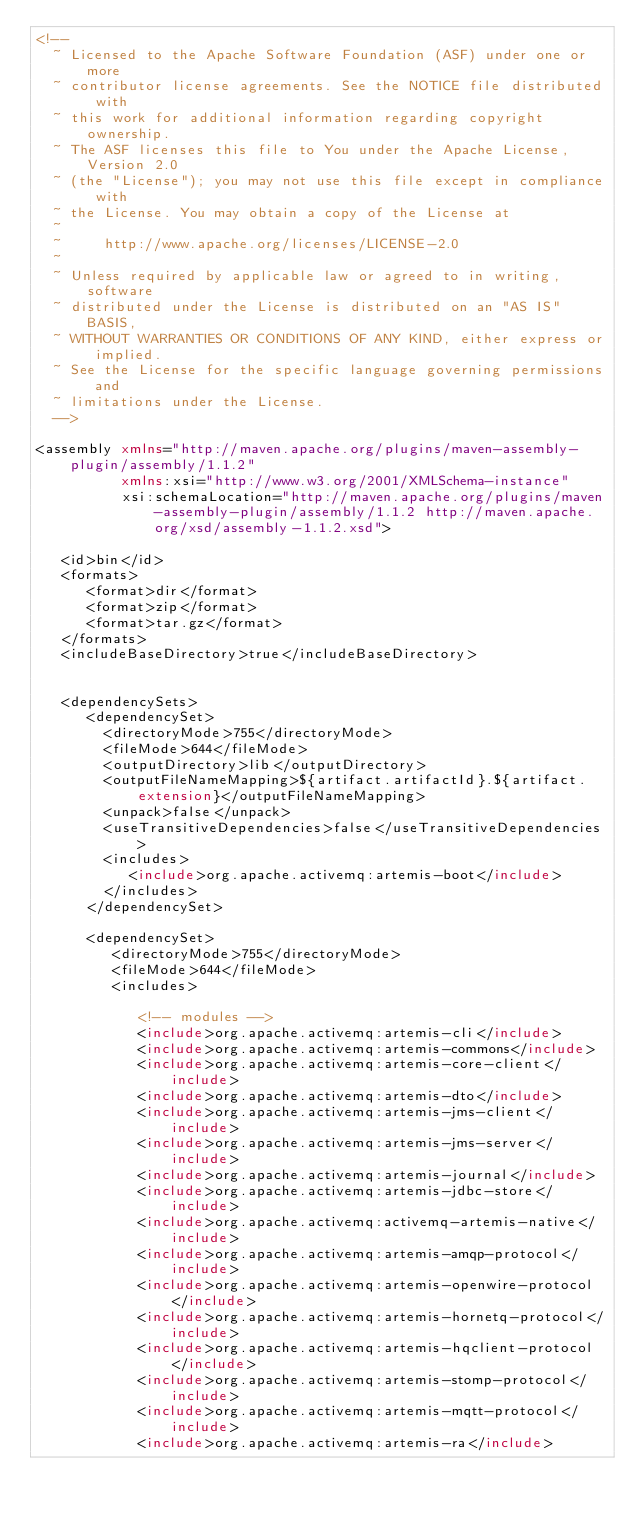Convert code to text. <code><loc_0><loc_0><loc_500><loc_500><_XML_><!--
  ~ Licensed to the Apache Software Foundation (ASF) under one or more
  ~ contributor license agreements. See the NOTICE file distributed with
  ~ this work for additional information regarding copyright ownership.
  ~ The ASF licenses this file to You under the Apache License, Version 2.0
  ~ (the "License"); you may not use this file except in compliance with
  ~ the License. You may obtain a copy of the License at
  ~
  ~     http://www.apache.org/licenses/LICENSE-2.0
  ~
  ~ Unless required by applicable law or agreed to in writing, software
  ~ distributed under the License is distributed on an "AS IS" BASIS,
  ~ WITHOUT WARRANTIES OR CONDITIONS OF ANY KIND, either express or implied.
  ~ See the License for the specific language governing permissions and
  ~ limitations under the License.
  -->

<assembly xmlns="http://maven.apache.org/plugins/maven-assembly-plugin/assembly/1.1.2"
          xmlns:xsi="http://www.w3.org/2001/XMLSchema-instance"
          xsi:schemaLocation="http://maven.apache.org/plugins/maven-assembly-plugin/assembly/1.1.2 http://maven.apache.org/xsd/assembly-1.1.2.xsd">

   <id>bin</id>
   <formats>
      <format>dir</format>
      <format>zip</format>
      <format>tar.gz</format>
   </formats>
   <includeBaseDirectory>true</includeBaseDirectory>


   <dependencySets>
      <dependencySet>
        <directoryMode>755</directoryMode>
        <fileMode>644</fileMode>
        <outputDirectory>lib</outputDirectory>
        <outputFileNameMapping>${artifact.artifactId}.${artifact.extension}</outputFileNameMapping>
        <unpack>false</unpack>
        <useTransitiveDependencies>false</useTransitiveDependencies>
        <includes>
           <include>org.apache.activemq:artemis-boot</include>
        </includes>
      </dependencySet>

      <dependencySet>
         <directoryMode>755</directoryMode>
         <fileMode>644</fileMode>
         <includes>

            <!-- modules -->
            <include>org.apache.activemq:artemis-cli</include>
            <include>org.apache.activemq:artemis-commons</include>
            <include>org.apache.activemq:artemis-core-client</include>
            <include>org.apache.activemq:artemis-dto</include>
            <include>org.apache.activemq:artemis-jms-client</include>
            <include>org.apache.activemq:artemis-jms-server</include>
            <include>org.apache.activemq:artemis-journal</include>
            <include>org.apache.activemq:artemis-jdbc-store</include>
            <include>org.apache.activemq:activemq-artemis-native</include>
            <include>org.apache.activemq:artemis-amqp-protocol</include>
            <include>org.apache.activemq:artemis-openwire-protocol</include>
            <include>org.apache.activemq:artemis-hornetq-protocol</include>
            <include>org.apache.activemq:artemis-hqclient-protocol</include>
            <include>org.apache.activemq:artemis-stomp-protocol</include>
            <include>org.apache.activemq:artemis-mqtt-protocol</include>
            <include>org.apache.activemq:artemis-ra</include></code> 